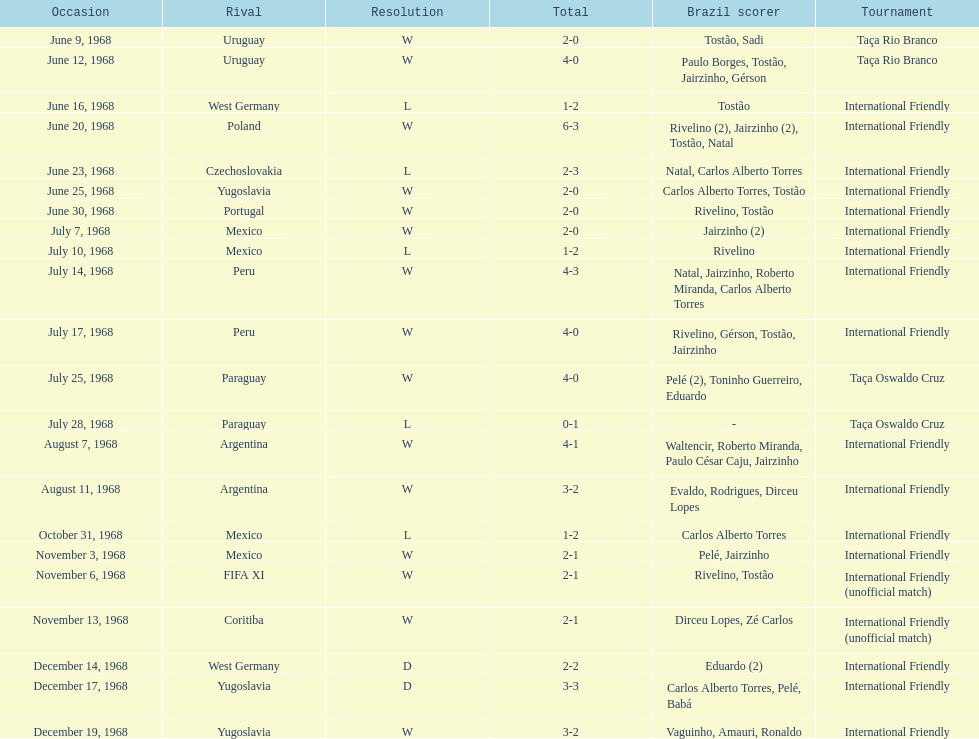How many matches are wins? 15. 